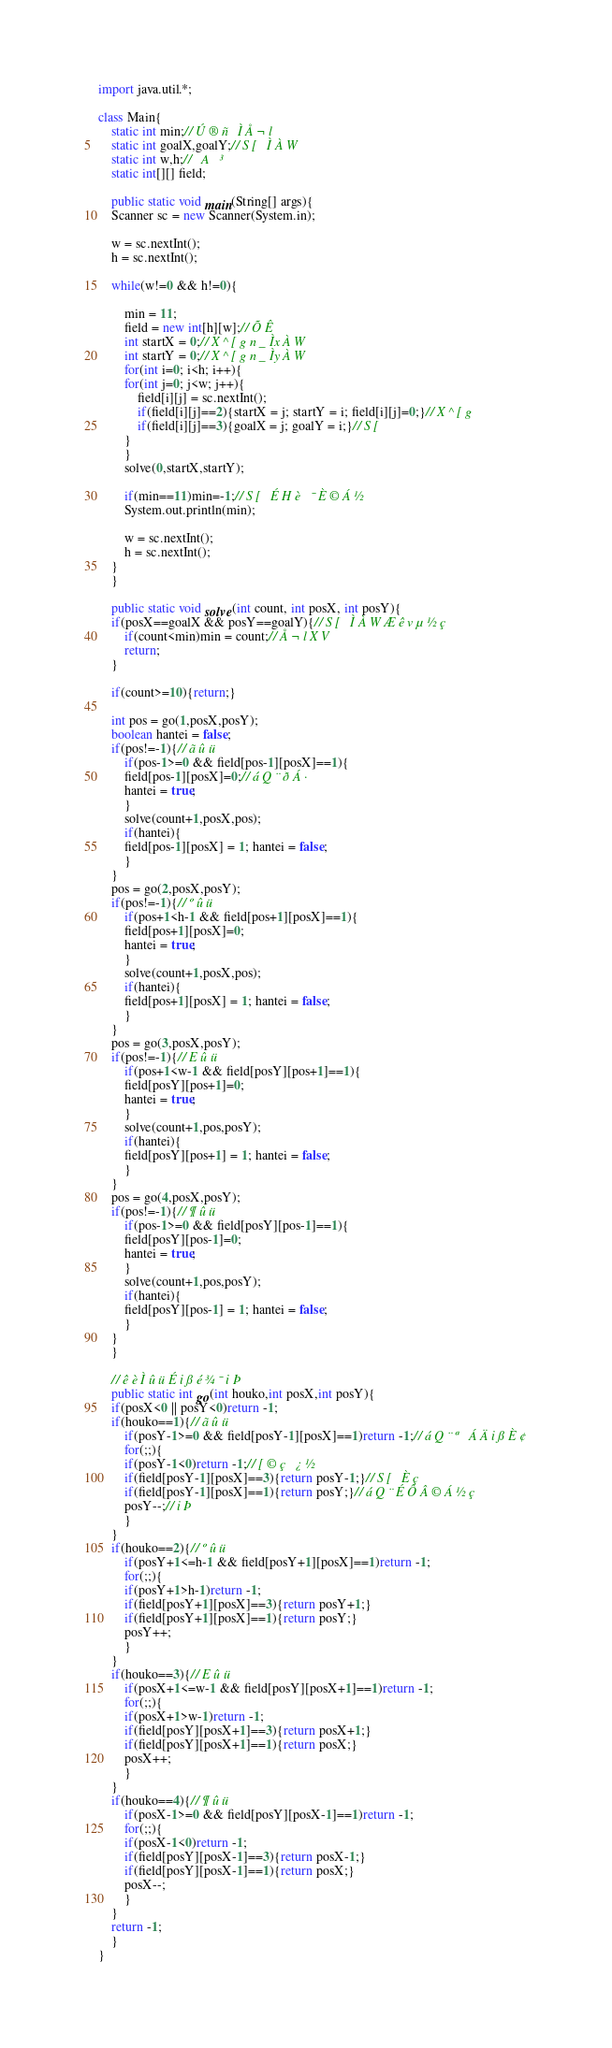<code> <loc_0><loc_0><loc_500><loc_500><_Java_>import java.util.*;

class Main{
    static int min;//Ú®ñÌÅ¬l
    static int goalX,goalY;//S[ÌÀW
    static int w,h;//A³
    static int[][] field;

    public static void main(String[] args){
	Scanner sc = new Scanner(System.in);

	w = sc.nextInt();
	h = sc.nextInt();

	while(w!=0 && h!=0){

	    min = 11;
	    field = new int[h][w];//ÕÊ
	    int startX = 0;//X^[gn_ÌxÀW
	    int startY = 0;//X^[gn_ÌyÀW
	    for(int i=0; i<h; i++){
		for(int j=0; j<w; j++){
		    field[i][j] = sc.nextInt();
		    if(field[i][j]==2){startX = j; startY = i; field[i][j]=0;}//X^[g
		    if(field[i][j]==3){goalX = j; goalY = i;}//S[
		}
	    }
	    solve(0,startX,startY);

	    if(min==11)min=-1;//S[ÉHè¯È©Á½
	    System.out.println(min);

	    w = sc.nextInt();
	    h = sc.nextInt();
	}
    }

    public static void solve(int count, int posX, int posY){
	if(posX==goalX && posY==goalY){//S[ÌÀWÆêvµ½ç
	    if(count<min)min = count;//Å¬lXV
	    return;
	}
	
	if(count>=10){return;}

	int pos = go(1,posX,posY);
	boolean hantei = false;
	if(pos!=-1){//ãûü
	    if(pos-1>=0 && field[pos-1][posX]==1){
		field[pos-1][posX]=0;//áQ¨ðÁ·
		hantei = true;
	    }
	    solve(count+1,posX,pos);
	    if(hantei){
		field[pos-1][posX] = 1; hantei = false;
	    }
	}
	pos = go(2,posX,posY);
	if(pos!=-1){//ºûü
	    if(pos+1<h-1 && field[pos+1][posX]==1){
		field[pos+1][posX]=0;
		hantei = true;
	    }
	    solve(count+1,posX,pos);
	    if(hantei){
		field[pos+1][posX] = 1; hantei = false;
	    }
	}
	pos = go(3,posX,posY);
	if(pos!=-1){//Eûü
	    if(pos+1<w-1 && field[posY][pos+1]==1){
		field[posY][pos+1]=0;
		hantei = true;
	    }
	    solve(count+1,pos,posY);
	    if(hantei){
		field[posY][pos+1] = 1; hantei = false;
	    }
	}
	pos = go(4,posX,posY);
	if(pos!=-1){//¶ûü
	    if(pos-1>=0 && field[posY][pos-1]==1){
		field[posY][pos-1]=0;
		hantei = true;
	    }
	    solve(count+1,pos,posY);
	    if(hantei){
		field[posY][pos-1] = 1; hantei = false;
	    }
	}
    }

    //êèÌûüÉißé¾¯iÞ
    public static int go(int houko,int posX,int posY){
	if(posX<0 || posY<0)return -1;
	if(houko==1){//ãûü
	    if(posY-1>=0 && field[posY-1][posX]==1)return -1;//áQ¨ª ÁÄißÈ¢
	    for(;;){
		if(posY-1<0)return -1;//[©ç¿½
		if(field[posY-1][posX]==3){return posY-1;}//S[Èç
		if(field[posY-1][posX]==1){return posY;}//áQ¨ÉÔÂ©Á½ç
		posY--;//iÞ
	    }
	}
	if(houko==2){//ºûü
	    if(posY+1<=h-1 && field[posY+1][posX]==1)return -1;
	    for(;;){
		if(posY+1>h-1)return -1;
		if(field[posY+1][posX]==3){return posY+1;}
		if(field[posY+1][posX]==1){return posY;}
		posY++;
	    }
	}
	if(houko==3){//Eûü
	    if(posX+1<=w-1 && field[posY][posX+1]==1)return -1;
	    for(;;){
		if(posX+1>w-1)return -1;
		if(field[posY][posX+1]==3){return posX+1;}
		if(field[posY][posX+1]==1){return posX;}
		posX++;
	    }
	}
	if(houko==4){//¶ûü
	    if(posX-1>=0 && field[posY][posX-1]==1)return -1;
	    for(;;){
		if(posX-1<0)return -1;
		if(field[posY][posX-1]==3){return posX-1;}
		if(field[posY][posX-1]==1){return posX;}
		posX--;
	    }
	}
	return -1;
    }
}</code> 